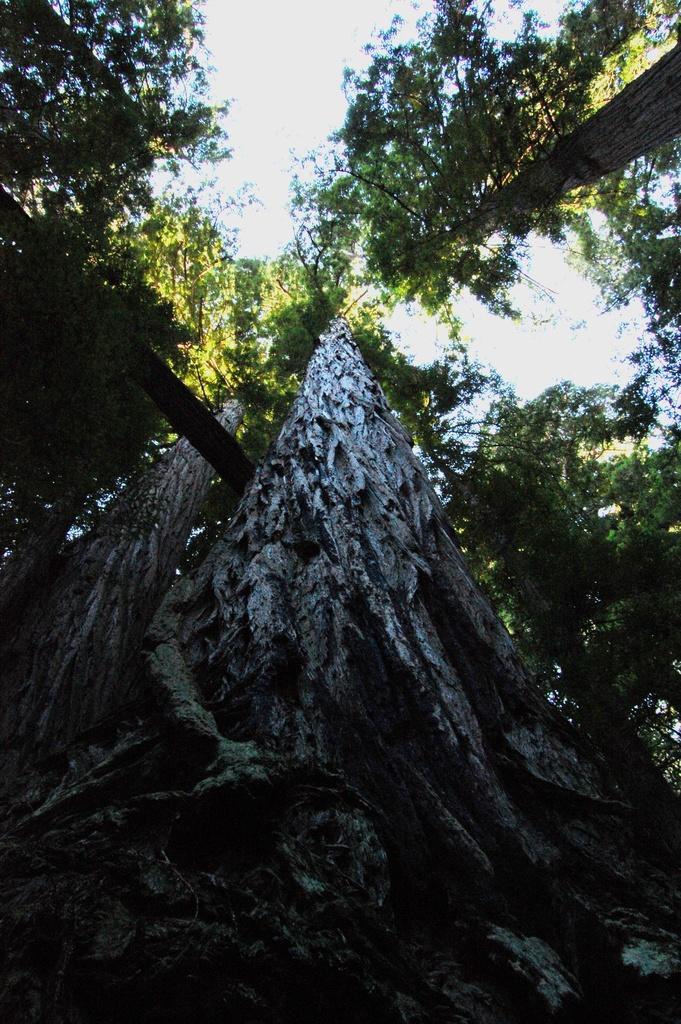Please provide a concise description of this image. In this picture I can see few tall trees and a cloudy sky. 